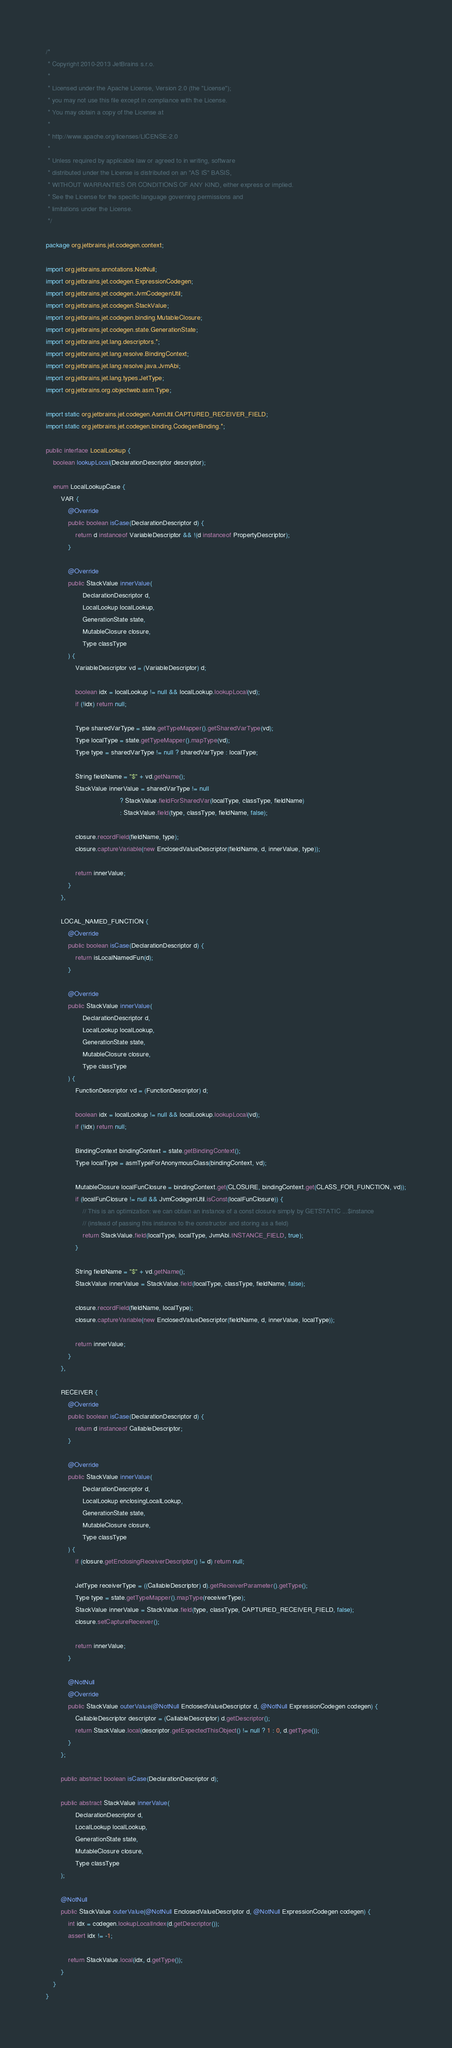Convert code to text. <code><loc_0><loc_0><loc_500><loc_500><_Java_>/*
 * Copyright 2010-2013 JetBrains s.r.o.
 *
 * Licensed under the Apache License, Version 2.0 (the "License");
 * you may not use this file except in compliance with the License.
 * You may obtain a copy of the License at
 *
 * http://www.apache.org/licenses/LICENSE-2.0
 *
 * Unless required by applicable law or agreed to in writing, software
 * distributed under the License is distributed on an "AS IS" BASIS,
 * WITHOUT WARRANTIES OR CONDITIONS OF ANY KIND, either express or implied.
 * See the License for the specific language governing permissions and
 * limitations under the License.
 */

package org.jetbrains.jet.codegen.context;

import org.jetbrains.annotations.NotNull;
import org.jetbrains.jet.codegen.ExpressionCodegen;
import org.jetbrains.jet.codegen.JvmCodegenUtil;
import org.jetbrains.jet.codegen.StackValue;
import org.jetbrains.jet.codegen.binding.MutableClosure;
import org.jetbrains.jet.codegen.state.GenerationState;
import org.jetbrains.jet.lang.descriptors.*;
import org.jetbrains.jet.lang.resolve.BindingContext;
import org.jetbrains.jet.lang.resolve.java.JvmAbi;
import org.jetbrains.jet.lang.types.JetType;
import org.jetbrains.org.objectweb.asm.Type;

import static org.jetbrains.jet.codegen.AsmUtil.CAPTURED_RECEIVER_FIELD;
import static org.jetbrains.jet.codegen.binding.CodegenBinding.*;

public interface LocalLookup {
    boolean lookupLocal(DeclarationDescriptor descriptor);

    enum LocalLookupCase {
        VAR {
            @Override
            public boolean isCase(DeclarationDescriptor d) {
                return d instanceof VariableDescriptor && !(d instanceof PropertyDescriptor);
            }

            @Override
            public StackValue innerValue(
                    DeclarationDescriptor d,
                    LocalLookup localLookup,
                    GenerationState state,
                    MutableClosure closure,
                    Type classType
            ) {
                VariableDescriptor vd = (VariableDescriptor) d;

                boolean idx = localLookup != null && localLookup.lookupLocal(vd);
                if (!idx) return null;

                Type sharedVarType = state.getTypeMapper().getSharedVarType(vd);
                Type localType = state.getTypeMapper().mapType(vd);
                Type type = sharedVarType != null ? sharedVarType : localType;

                String fieldName = "$" + vd.getName();
                StackValue innerValue = sharedVarType != null
                                        ? StackValue.fieldForSharedVar(localType, classType, fieldName)
                                        : StackValue.field(type, classType, fieldName, false);

                closure.recordField(fieldName, type);
                closure.captureVariable(new EnclosedValueDescriptor(fieldName, d, innerValue, type));

                return innerValue;
            }
        },

        LOCAL_NAMED_FUNCTION {
            @Override
            public boolean isCase(DeclarationDescriptor d) {
                return isLocalNamedFun(d);
            }

            @Override
            public StackValue innerValue(
                    DeclarationDescriptor d,
                    LocalLookup localLookup,
                    GenerationState state,
                    MutableClosure closure,
                    Type classType
            ) {
                FunctionDescriptor vd = (FunctionDescriptor) d;

                boolean idx = localLookup != null && localLookup.lookupLocal(vd);
                if (!idx) return null;

                BindingContext bindingContext = state.getBindingContext();
                Type localType = asmTypeForAnonymousClass(bindingContext, vd);

                MutableClosure localFunClosure = bindingContext.get(CLOSURE, bindingContext.get(CLASS_FOR_FUNCTION, vd));
                if (localFunClosure != null && JvmCodegenUtil.isConst(localFunClosure)) {
                    // This is an optimization: we can obtain an instance of a const closure simply by GETSTATIC ...$instance
                    // (instead of passing this instance to the constructor and storing as a field)
                    return StackValue.field(localType, localType, JvmAbi.INSTANCE_FIELD, true);
                }

                String fieldName = "$" + vd.getName();
                StackValue innerValue = StackValue.field(localType, classType, fieldName, false);

                closure.recordField(fieldName, localType);
                closure.captureVariable(new EnclosedValueDescriptor(fieldName, d, innerValue, localType));

                return innerValue;
            }
        },

        RECEIVER {
            @Override
            public boolean isCase(DeclarationDescriptor d) {
                return d instanceof CallableDescriptor;
            }

            @Override
            public StackValue innerValue(
                    DeclarationDescriptor d,
                    LocalLookup enclosingLocalLookup,
                    GenerationState state,
                    MutableClosure closure,
                    Type classType
            ) {
                if (closure.getEnclosingReceiverDescriptor() != d) return null;

                JetType receiverType = ((CallableDescriptor) d).getReceiverParameter().getType();
                Type type = state.getTypeMapper().mapType(receiverType);
                StackValue innerValue = StackValue.field(type, classType, CAPTURED_RECEIVER_FIELD, false);
                closure.setCaptureReceiver();

                return innerValue;
            }

            @NotNull
            @Override
            public StackValue outerValue(@NotNull EnclosedValueDescriptor d, @NotNull ExpressionCodegen codegen) {
                CallableDescriptor descriptor = (CallableDescriptor) d.getDescriptor();
                return StackValue.local(descriptor.getExpectedThisObject() != null ? 1 : 0, d.getType());
            }
        };

        public abstract boolean isCase(DeclarationDescriptor d);

        public abstract StackValue innerValue(
                DeclarationDescriptor d,
                LocalLookup localLookup,
                GenerationState state,
                MutableClosure closure,
                Type classType
        );

        @NotNull
        public StackValue outerValue(@NotNull EnclosedValueDescriptor d, @NotNull ExpressionCodegen codegen) {
            int idx = codegen.lookupLocalIndex(d.getDescriptor());
            assert idx != -1;

            return StackValue.local(idx, d.getType());
        }
    }
}
</code> 